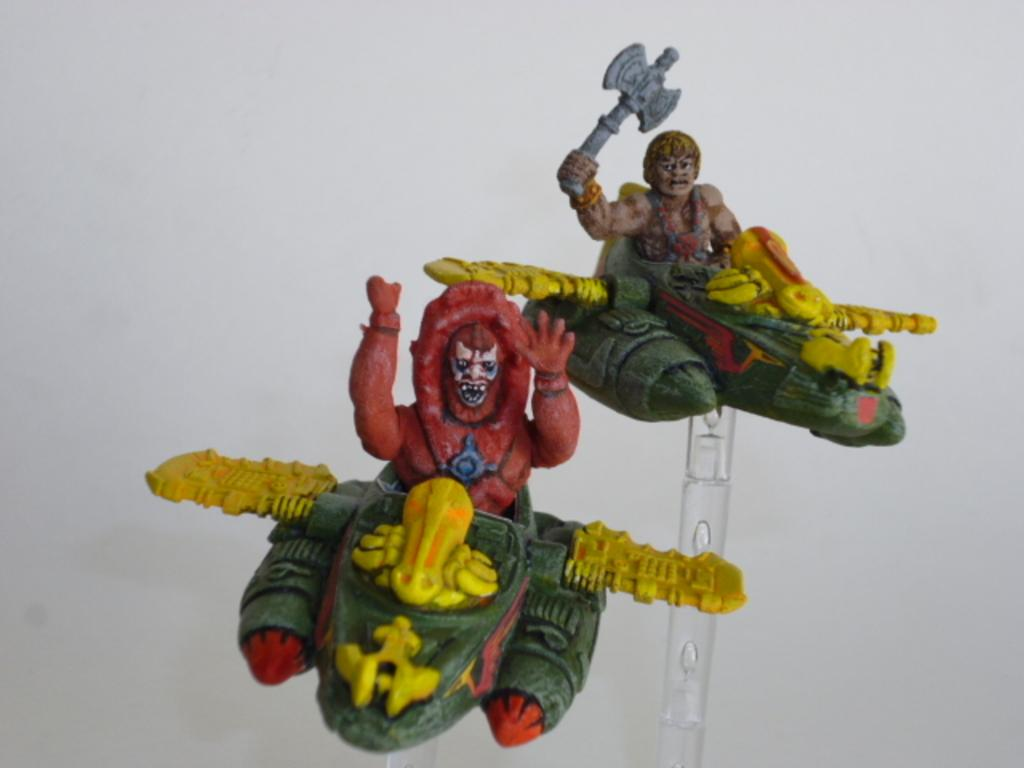What objects are present in the image that resemble playthings? There are two toys in the image. What is the man in the image doing? The man is sitting in a green color plane. What color is the background of the image? The background of the image is white. What type of boot is the man wearing in the image? There is no boot visible in the image; the man is sitting in a green color plane. Is there a gun present in the image? No, there is no gun present in the image. 